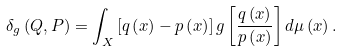Convert formula to latex. <formula><loc_0><loc_0><loc_500><loc_500>\delta _ { g } \left ( Q , P \right ) = \int _ { X } \left [ q \left ( x \right ) - p \left ( x \right ) \right ] g \left [ \frac { q \left ( x \right ) } { p \left ( x \right ) } \right ] d \mu \left ( x \right ) .</formula> 